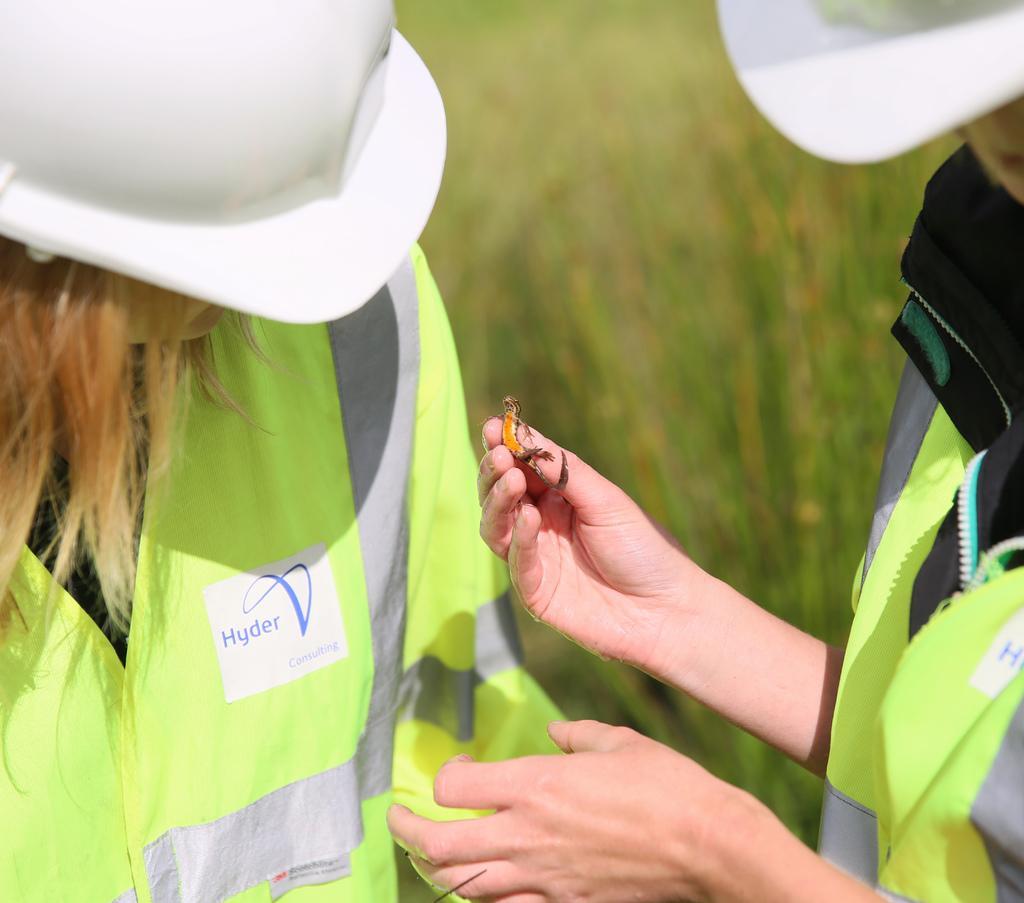Could you give a brief overview of what you see in this image? On the right side a person is holding the lizard in the hand, this person wore green color coat. On the left side there is a beautiful woman, she is looking at the that. She wore green color coat and a white color helmet. 